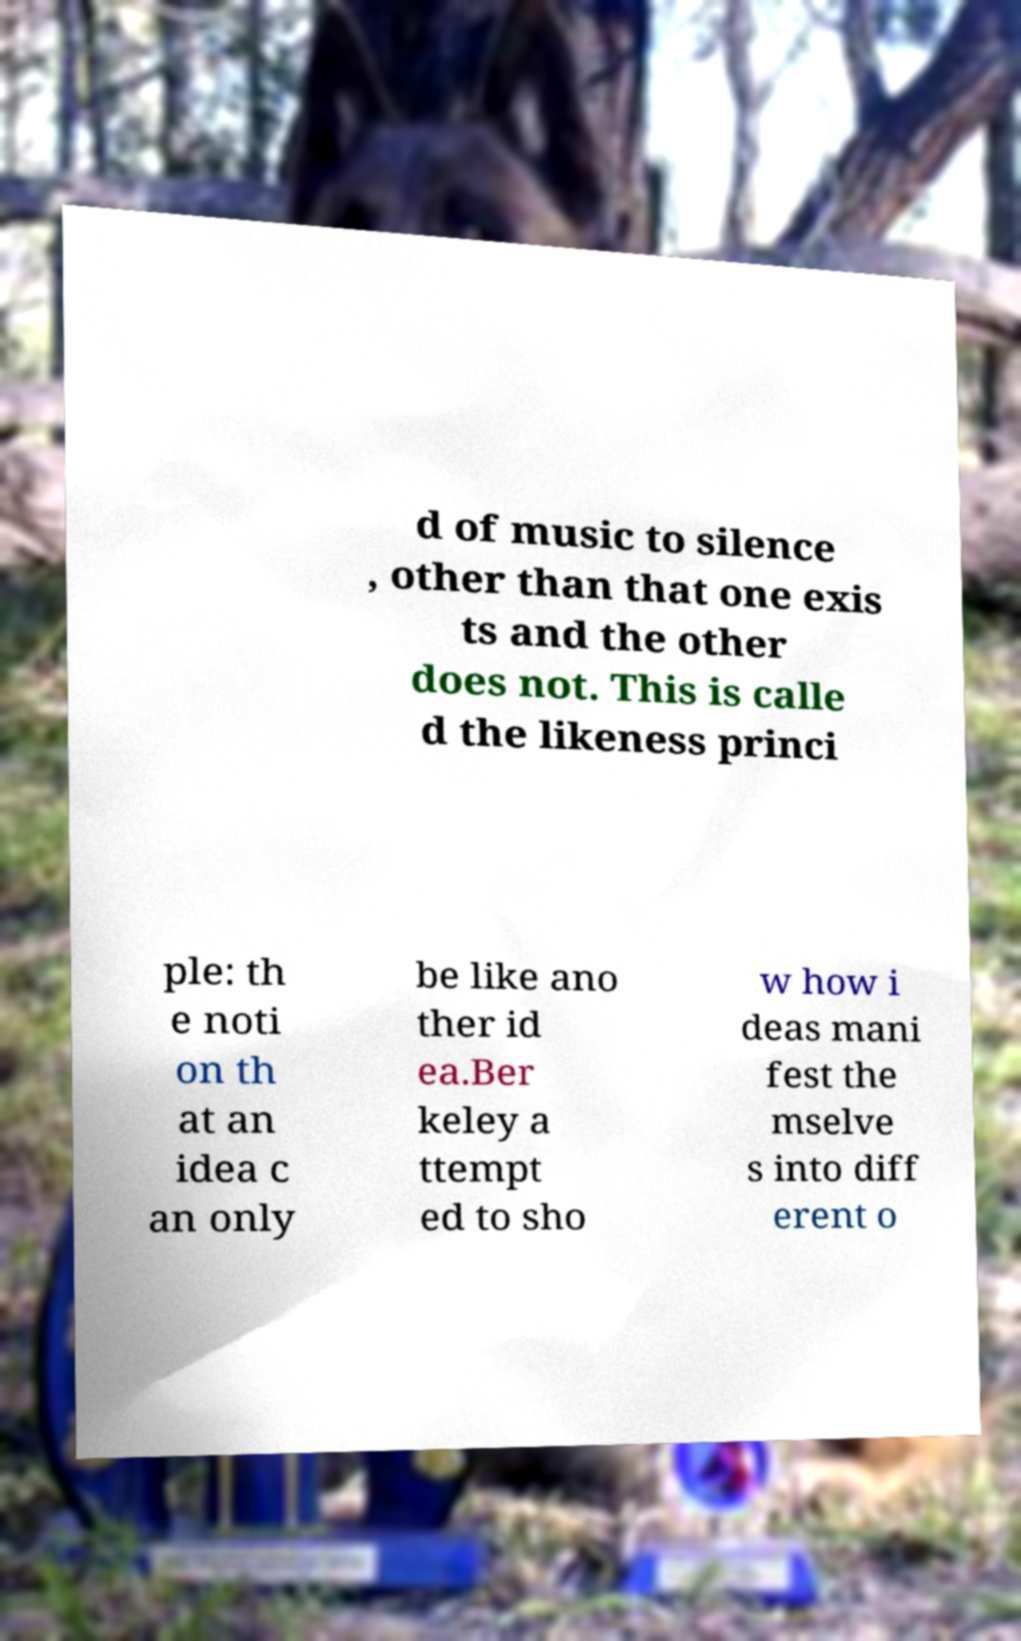Please read and relay the text visible in this image. What does it say? d of music to silence , other than that one exis ts and the other does not. This is calle d the likeness princi ple: th e noti on th at an idea c an only be like ano ther id ea.Ber keley a ttempt ed to sho w how i deas mani fest the mselve s into diff erent o 